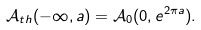<formula> <loc_0><loc_0><loc_500><loc_500>\mathcal { A } _ { t h } ( - \infty , a ) = \mathcal { A } _ { 0 } ( 0 , e ^ { 2 \pi a } ) .</formula> 